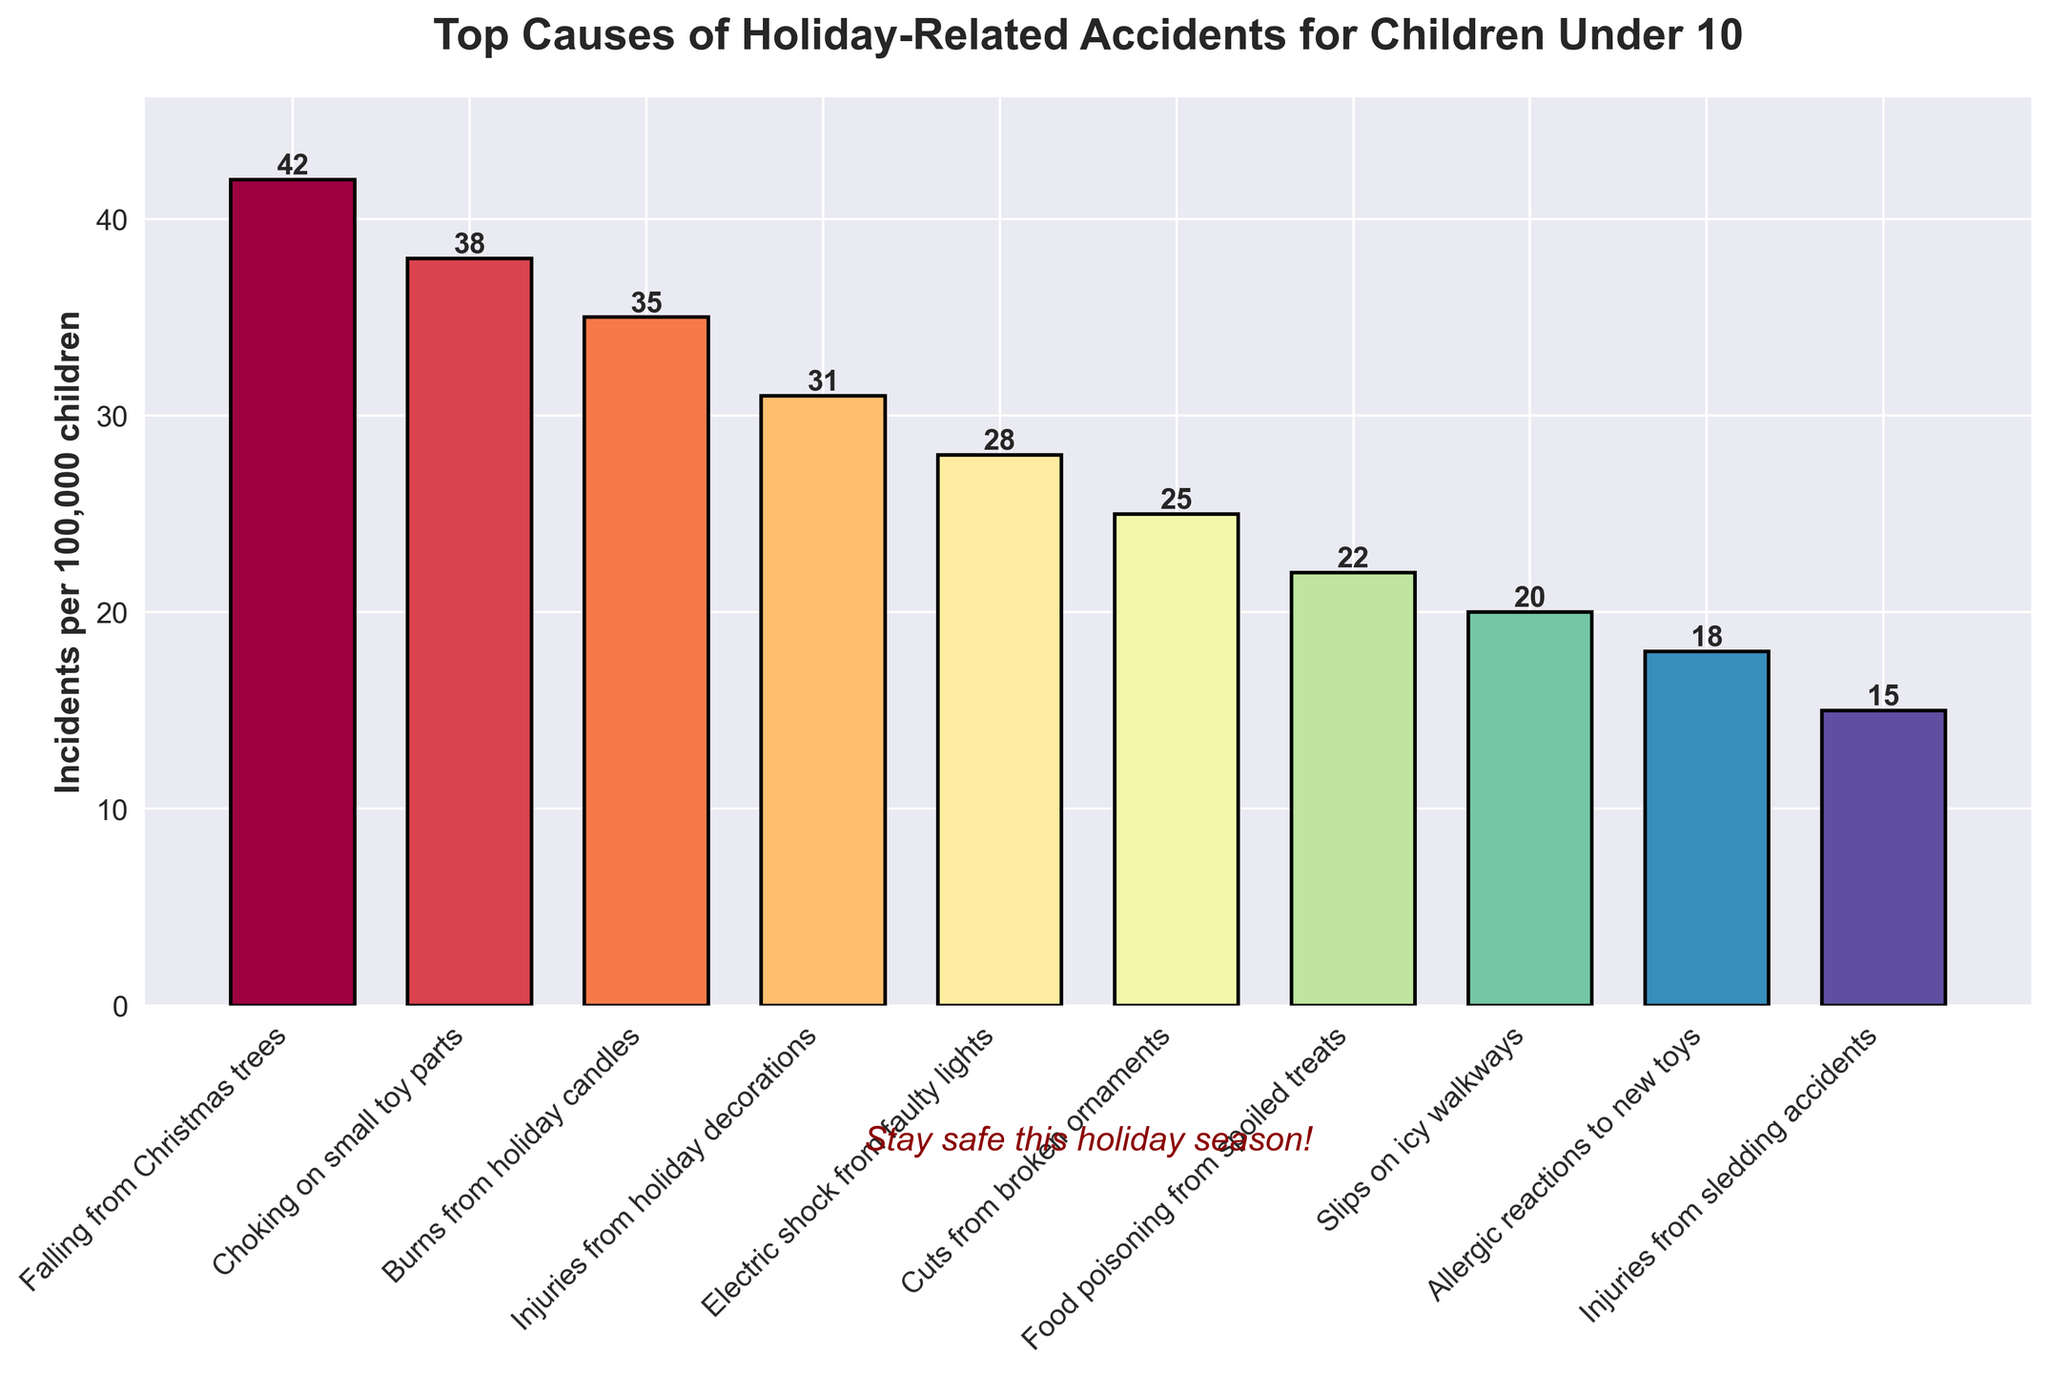What's the most common cause of holiday-related accidents for children under 10? The bar representing "Falling from Christmas trees" is the tallest in the figure, indicating it has the highest number of incidents per 100k children.
Answer: Falling from Christmas trees Which accident cause has the least incidents per 100k children? The bar for "Injuries from sledding accidents" is the shortest in the figure, indicating it has the lowest number of incidents per 100k children.
Answer: Injuries from sledding accidents How many more incidents are caused by falling from Christmas trees compared to slips on icy walkways? The number of incidents for "Falling from Christmas trees" is 42 and for "Slips on icy walkways" is 20. The difference is 42 - 20 = 22.
Answer: 22 What is the total number of incidents for choking on small toy parts, burns from holiday candles, and cuts from broken ornaments? The number of incidents for "Choking on small toy parts" is 38, "Burns from holiday candles" is 35, and "Cuts from broken ornaments" is 25. The total is 38 + 35 + 25 = 98.
Answer: 98 What is the average number of incidents for the top three causes? The top three causes are "Falling from Christmas trees" (42), "Choking on small toy parts" (38), and "Burns from holiday candles" (35). The average is (42 + 38 + 35) / 3 = 115 / 3 = 38.33.
Answer: 38.33 Which causes have fewer incidents than electric shock from faulty lights? The number of incidents for "Electric shock from faulty lights" is 28. Causes with fewer incidents are "Cuts from broken ornaments" (25), "Food poisoning from spoiled treats" (22), "Slips on icy walkways" (20), "Allergic reactions to new toys" (18), and "Injuries from sledding accidents" (15).
Answer: Cuts from broken ornaments, Food poisoning from spoiled treats, Slips on icy walkways, Allergic reactions to new toys, Injuries from sledding accidents How many more incidents are there for burns from holiday candles compared to allergic reactions to new toys? The number of incidents for "Burns from holiday candles" is 35 and for "Allergic reactions to new toys" is 18. The difference is 35 - 18 = 17.
Answer: 17 What is the combined total of incidents for injuries from holiday decorations and food poisoning from spoiled treats? The number of incidents for "Injuries from holiday decorations" is 31 and for "Food poisoning from spoiled treats" is 22. The total is 31 + 22 = 53.
Answer: 53 Which cause of accidents has exactly 25 incidents per 100k children? The figure shows that "Cuts from broken ornaments" has exactly 25 incidents per 100k children.
Answer: Cuts from broken ornaments 